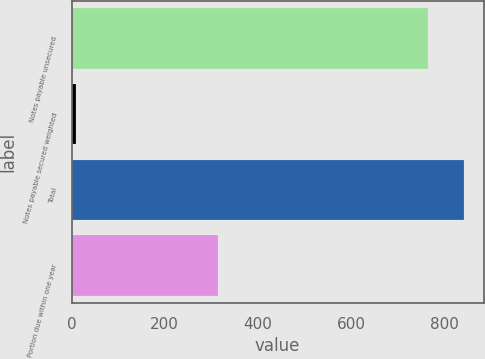<chart> <loc_0><loc_0><loc_500><loc_500><bar_chart><fcel>Notes payable unsecured<fcel>Notes payable secured weighted<fcel>Total<fcel>Portion due within one year<nl><fcel>766<fcel>9<fcel>842.6<fcel>314<nl></chart> 